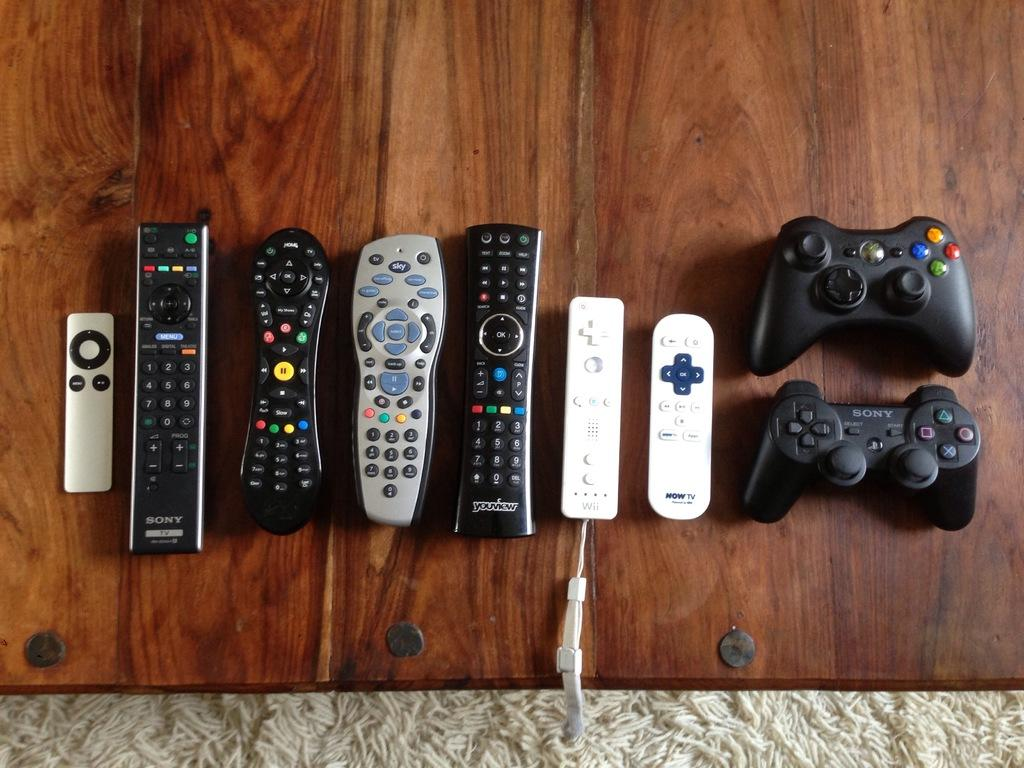<image>
Provide a brief description of the given image. a collection of tv and video game remotes including Wii and xbox 